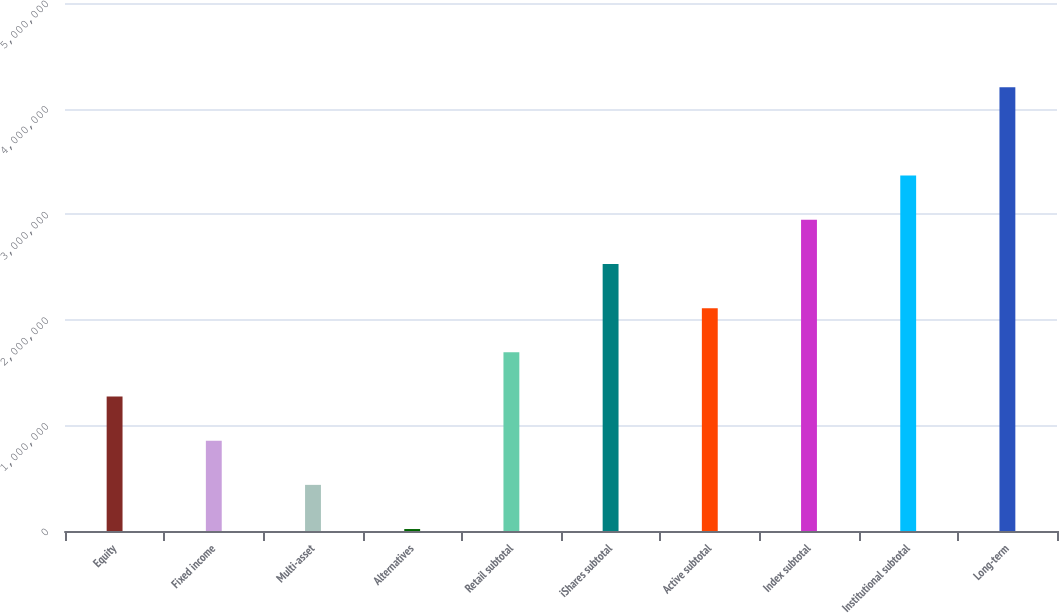Convert chart. <chart><loc_0><loc_0><loc_500><loc_500><bar_chart><fcel>Equity<fcel>Fixed income<fcel>Multi-asset<fcel>Alternatives<fcel>Retail subtotal<fcel>iShares subtotal<fcel>Active subtotal<fcel>Index subtotal<fcel>Institutional subtotal<fcel>Long-term<nl><fcel>1.27358e+06<fcel>855217<fcel>436852<fcel>18487<fcel>1.69195e+06<fcel>2.52868e+06<fcel>2.11031e+06<fcel>2.94704e+06<fcel>3.36541e+06<fcel>4.20214e+06<nl></chart> 